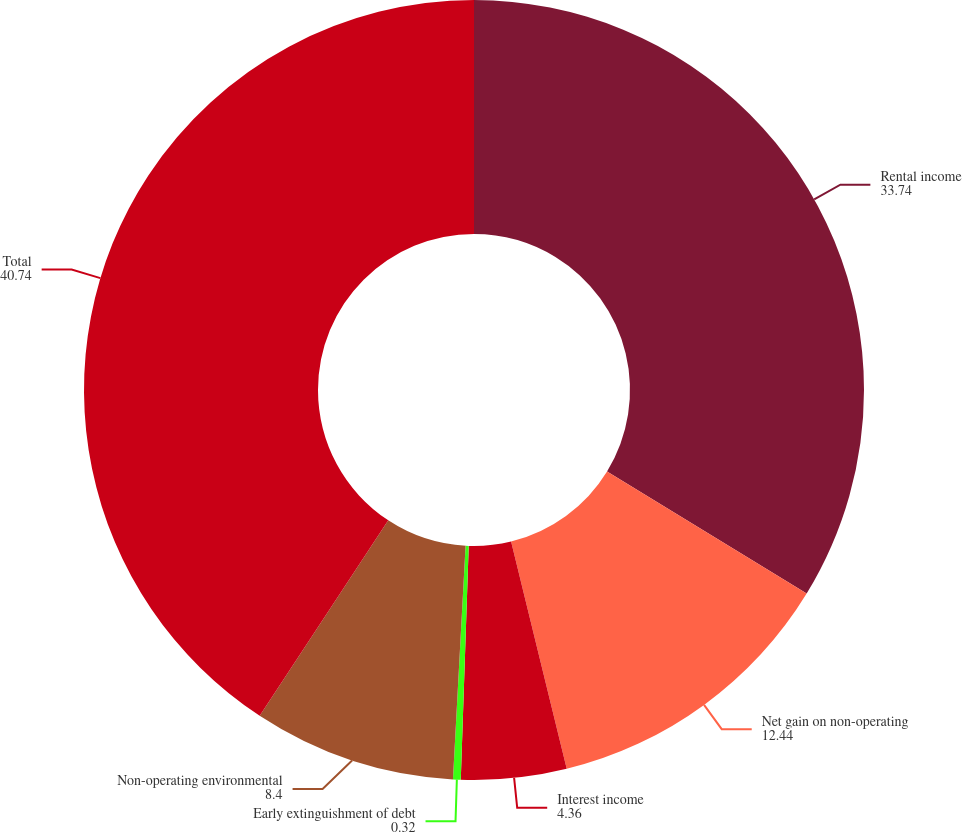Convert chart. <chart><loc_0><loc_0><loc_500><loc_500><pie_chart><fcel>Rental income<fcel>Net gain on non-operating<fcel>Interest income<fcel>Early extinguishment of debt<fcel>Non-operating environmental<fcel>Total<nl><fcel>33.74%<fcel>12.44%<fcel>4.36%<fcel>0.32%<fcel>8.4%<fcel>40.74%<nl></chart> 